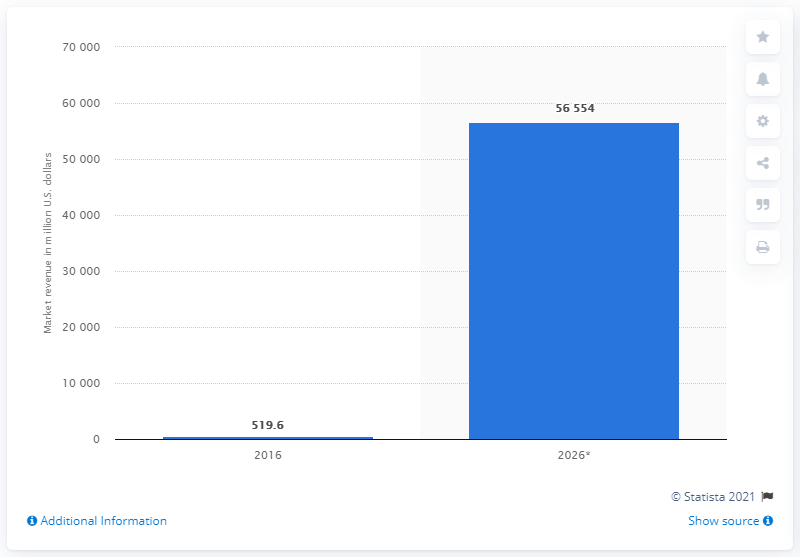Highlight a few significant elements in this photo. In 2016, the beacons technology market in the US had a value of 519.6 million US dollars. According to our data, the market size of the beacons technology market in 2026 was 56,554. 